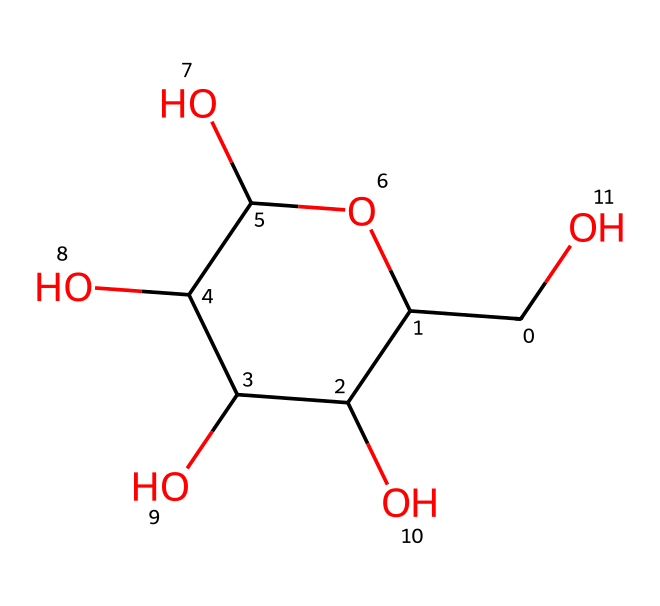What is the molecular formula of glucose based on its structure? To determine the molecular formula, count the number of carbon (C), hydrogen (H), and oxygen (O) atoms in the structure shown by the SMILES. There are six carbon atoms, twelve hydrogen atoms, and six oxygen atoms in glucose. Thus, the formula is C6H12O6.
Answer: C6H12O6 How many hydroxyl (-OH) groups are present in the glucose structure? By examining the structure, we look for the hydroxyl (-OH) groups attached to the carbon atoms. There are five hydroxyl groups in the glucose structure.
Answer: five What type of carbohydrate is glucose classified as? Glucose is analyzed based on its structure, showing it is a monosaccharide, as it consists of a single sugar unit and cannot be hydrolyzed into simpler sugars.
Answer: monosaccharide What is the number of carbon atoms in the cyclic form of glucose? In the cyclic representation of glucose, we identify the carbon atoms. There are six carbon atoms present in the cyclic structure, forming a ring.
Answer: six What type of cyclic structure does glucose primarily form? By analyzing the cyclic structure and the configuration of the hydroxyl groups, the primary cyclic form is determined to be a pyranose, which has a six-membered ring.
Answer: pyranose What is the anomeric carbon in glucose? The anomeric carbon is identified as the carbon atom that is involved in the formation of the glycosidic bond in the cyclic form. In glucose, this is carbon 1, which becomes a new chiral center when it is converted from a linear to a cyclic form.
Answer: carbon 1 How does the cyclic form of glucose differ from its linear form? The cyclic form is characterized by the ring structure and the position of hydroxyl groups around the anomeric carbon, while the linear form has an open-chain structure with aldehyde functionality. This difference is a result of the carbon atoms' bonding arrangements in the two forms.
Answer: ring structure 